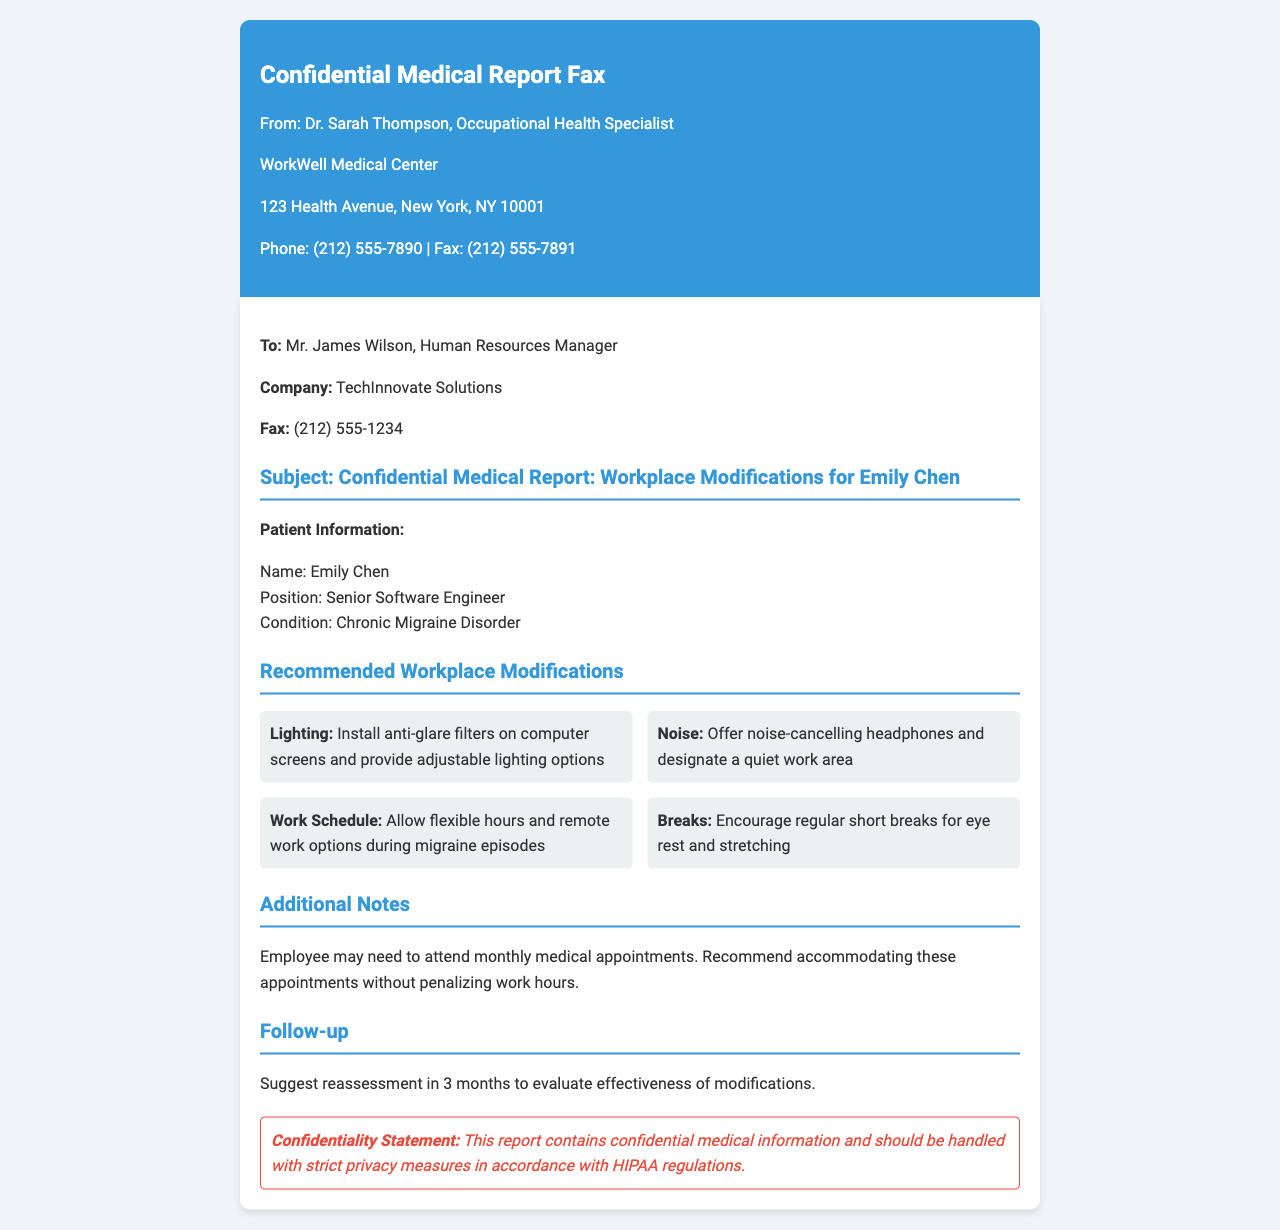What is the name of the patient? The name of the patient is specified in the patient information section of the document.
Answer: Emily Chen Who is the sender of the fax? The sender is mentioned at the top of the document in the fax header section.
Answer: Dr. Sarah Thompson What is the position of Emily Chen? The position is listed under patient information detailing the employee's role at the company.
Answer: Senior Software Engineer What condition does Emily Chen have? The medical condition of the patient is stated in the patient information section.
Answer: Chronic Migraine Disorder How many recommendations for workplace modifications are given? The number of recommendations can be counted in the recommended workplace modifications section.
Answer: Four What is one of the suggested modifications for lighting? One of the modifications regarding lighting can be found in the recommendations section.
Answer: Install anti-glare filters on computer screens How often may the employee need to attend medical appointments? The frequency of medical appointments is mentioned in the additional notes section.
Answer: Monthly What will be the follow-up period for reassessment? The timeframe for the follow-up is specified in the follow-up section of the document.
Answer: 3 months 